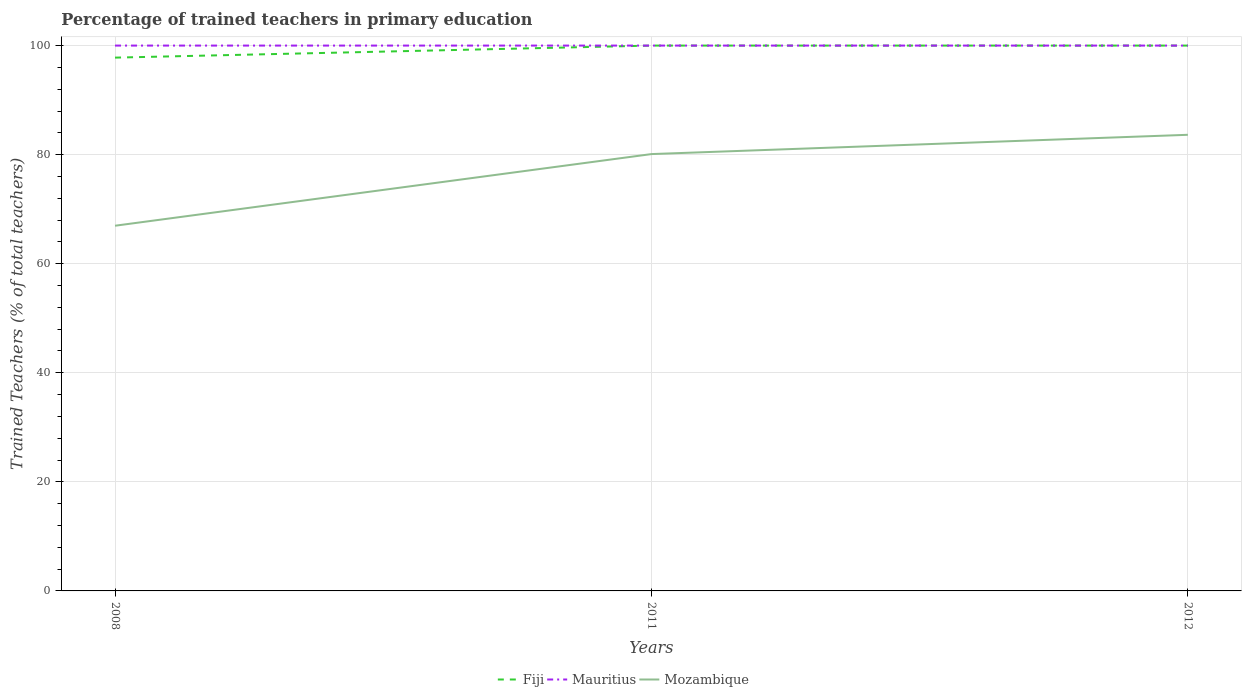How many different coloured lines are there?
Your response must be concise. 3. Is the number of lines equal to the number of legend labels?
Offer a terse response. Yes. Across all years, what is the maximum percentage of trained teachers in Fiji?
Make the answer very short. 97.79. What is the total percentage of trained teachers in Mauritius in the graph?
Your answer should be very brief. 0. What is the difference between the highest and the second highest percentage of trained teachers in Mauritius?
Your answer should be very brief. 0. What is the difference between the highest and the lowest percentage of trained teachers in Mozambique?
Ensure brevity in your answer.  2. How many years are there in the graph?
Give a very brief answer. 3. What is the difference between two consecutive major ticks on the Y-axis?
Give a very brief answer. 20. Does the graph contain any zero values?
Give a very brief answer. No. Does the graph contain grids?
Offer a very short reply. Yes. Where does the legend appear in the graph?
Provide a succinct answer. Bottom center. How are the legend labels stacked?
Provide a succinct answer. Horizontal. What is the title of the graph?
Ensure brevity in your answer.  Percentage of trained teachers in primary education. What is the label or title of the X-axis?
Keep it short and to the point. Years. What is the label or title of the Y-axis?
Provide a short and direct response. Trained Teachers (% of total teachers). What is the Trained Teachers (% of total teachers) in Fiji in 2008?
Give a very brief answer. 97.79. What is the Trained Teachers (% of total teachers) in Mauritius in 2008?
Offer a terse response. 100. What is the Trained Teachers (% of total teachers) of Mozambique in 2008?
Your answer should be very brief. 66.97. What is the Trained Teachers (% of total teachers) in Fiji in 2011?
Offer a very short reply. 100. What is the Trained Teachers (% of total teachers) of Mozambique in 2011?
Give a very brief answer. 80.1. What is the Trained Teachers (% of total teachers) of Mauritius in 2012?
Keep it short and to the point. 100. What is the Trained Teachers (% of total teachers) of Mozambique in 2012?
Ensure brevity in your answer.  83.64. Across all years, what is the maximum Trained Teachers (% of total teachers) in Fiji?
Give a very brief answer. 100. Across all years, what is the maximum Trained Teachers (% of total teachers) of Mauritius?
Make the answer very short. 100. Across all years, what is the maximum Trained Teachers (% of total teachers) of Mozambique?
Your response must be concise. 83.64. Across all years, what is the minimum Trained Teachers (% of total teachers) of Fiji?
Make the answer very short. 97.79. Across all years, what is the minimum Trained Teachers (% of total teachers) of Mauritius?
Give a very brief answer. 100. Across all years, what is the minimum Trained Teachers (% of total teachers) in Mozambique?
Provide a succinct answer. 66.97. What is the total Trained Teachers (% of total teachers) in Fiji in the graph?
Keep it short and to the point. 297.79. What is the total Trained Teachers (% of total teachers) of Mauritius in the graph?
Your answer should be compact. 300. What is the total Trained Teachers (% of total teachers) of Mozambique in the graph?
Your response must be concise. 230.71. What is the difference between the Trained Teachers (% of total teachers) of Fiji in 2008 and that in 2011?
Ensure brevity in your answer.  -2.21. What is the difference between the Trained Teachers (% of total teachers) in Mozambique in 2008 and that in 2011?
Offer a terse response. -13.14. What is the difference between the Trained Teachers (% of total teachers) of Fiji in 2008 and that in 2012?
Keep it short and to the point. -2.21. What is the difference between the Trained Teachers (% of total teachers) of Mozambique in 2008 and that in 2012?
Your response must be concise. -16.67. What is the difference between the Trained Teachers (% of total teachers) in Fiji in 2011 and that in 2012?
Give a very brief answer. 0. What is the difference between the Trained Teachers (% of total teachers) in Mauritius in 2011 and that in 2012?
Provide a succinct answer. 0. What is the difference between the Trained Teachers (% of total teachers) of Mozambique in 2011 and that in 2012?
Offer a terse response. -3.54. What is the difference between the Trained Teachers (% of total teachers) in Fiji in 2008 and the Trained Teachers (% of total teachers) in Mauritius in 2011?
Give a very brief answer. -2.21. What is the difference between the Trained Teachers (% of total teachers) of Fiji in 2008 and the Trained Teachers (% of total teachers) of Mozambique in 2011?
Give a very brief answer. 17.69. What is the difference between the Trained Teachers (% of total teachers) in Mauritius in 2008 and the Trained Teachers (% of total teachers) in Mozambique in 2011?
Make the answer very short. 19.9. What is the difference between the Trained Teachers (% of total teachers) in Fiji in 2008 and the Trained Teachers (% of total teachers) in Mauritius in 2012?
Your answer should be compact. -2.21. What is the difference between the Trained Teachers (% of total teachers) of Fiji in 2008 and the Trained Teachers (% of total teachers) of Mozambique in 2012?
Provide a short and direct response. 14.15. What is the difference between the Trained Teachers (% of total teachers) of Mauritius in 2008 and the Trained Teachers (% of total teachers) of Mozambique in 2012?
Your answer should be compact. 16.36. What is the difference between the Trained Teachers (% of total teachers) of Fiji in 2011 and the Trained Teachers (% of total teachers) of Mauritius in 2012?
Provide a short and direct response. 0. What is the difference between the Trained Teachers (% of total teachers) in Fiji in 2011 and the Trained Teachers (% of total teachers) in Mozambique in 2012?
Offer a very short reply. 16.36. What is the difference between the Trained Teachers (% of total teachers) of Mauritius in 2011 and the Trained Teachers (% of total teachers) of Mozambique in 2012?
Provide a succinct answer. 16.36. What is the average Trained Teachers (% of total teachers) of Fiji per year?
Ensure brevity in your answer.  99.26. What is the average Trained Teachers (% of total teachers) in Mozambique per year?
Provide a short and direct response. 76.9. In the year 2008, what is the difference between the Trained Teachers (% of total teachers) of Fiji and Trained Teachers (% of total teachers) of Mauritius?
Your answer should be very brief. -2.21. In the year 2008, what is the difference between the Trained Teachers (% of total teachers) in Fiji and Trained Teachers (% of total teachers) in Mozambique?
Keep it short and to the point. 30.82. In the year 2008, what is the difference between the Trained Teachers (% of total teachers) of Mauritius and Trained Teachers (% of total teachers) of Mozambique?
Make the answer very short. 33.03. In the year 2011, what is the difference between the Trained Teachers (% of total teachers) in Fiji and Trained Teachers (% of total teachers) in Mozambique?
Make the answer very short. 19.9. In the year 2011, what is the difference between the Trained Teachers (% of total teachers) of Mauritius and Trained Teachers (% of total teachers) of Mozambique?
Give a very brief answer. 19.9. In the year 2012, what is the difference between the Trained Teachers (% of total teachers) of Fiji and Trained Teachers (% of total teachers) of Mozambique?
Give a very brief answer. 16.36. In the year 2012, what is the difference between the Trained Teachers (% of total teachers) of Mauritius and Trained Teachers (% of total teachers) of Mozambique?
Offer a terse response. 16.36. What is the ratio of the Trained Teachers (% of total teachers) in Fiji in 2008 to that in 2011?
Give a very brief answer. 0.98. What is the ratio of the Trained Teachers (% of total teachers) in Mauritius in 2008 to that in 2011?
Ensure brevity in your answer.  1. What is the ratio of the Trained Teachers (% of total teachers) in Mozambique in 2008 to that in 2011?
Offer a terse response. 0.84. What is the ratio of the Trained Teachers (% of total teachers) of Fiji in 2008 to that in 2012?
Offer a terse response. 0.98. What is the ratio of the Trained Teachers (% of total teachers) of Mauritius in 2008 to that in 2012?
Ensure brevity in your answer.  1. What is the ratio of the Trained Teachers (% of total teachers) in Mozambique in 2008 to that in 2012?
Provide a short and direct response. 0.8. What is the ratio of the Trained Teachers (% of total teachers) in Mozambique in 2011 to that in 2012?
Ensure brevity in your answer.  0.96. What is the difference between the highest and the second highest Trained Teachers (% of total teachers) in Mozambique?
Your response must be concise. 3.54. What is the difference between the highest and the lowest Trained Teachers (% of total teachers) of Fiji?
Your answer should be compact. 2.21. What is the difference between the highest and the lowest Trained Teachers (% of total teachers) of Mauritius?
Provide a short and direct response. 0. What is the difference between the highest and the lowest Trained Teachers (% of total teachers) of Mozambique?
Make the answer very short. 16.67. 